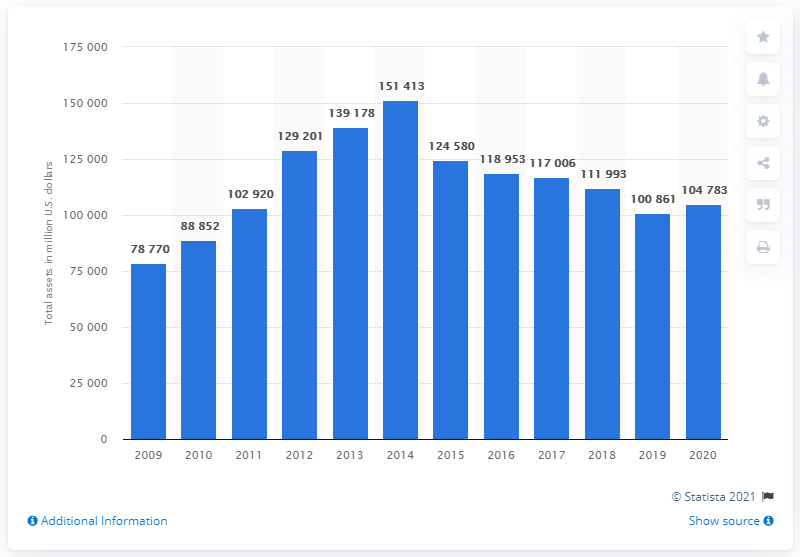Point out several critical features in this image. In 2020, BHP's total assets were 104,783 dollars. 